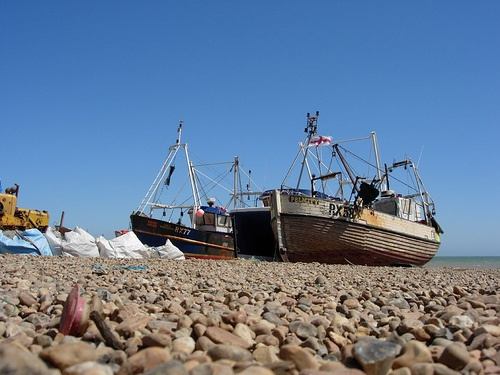Describe the objects in this image and their specific colors. I can see boat in blue, black, darkgray, and gray tones and boat in blue, black, darkgray, lightblue, and gray tones in this image. 